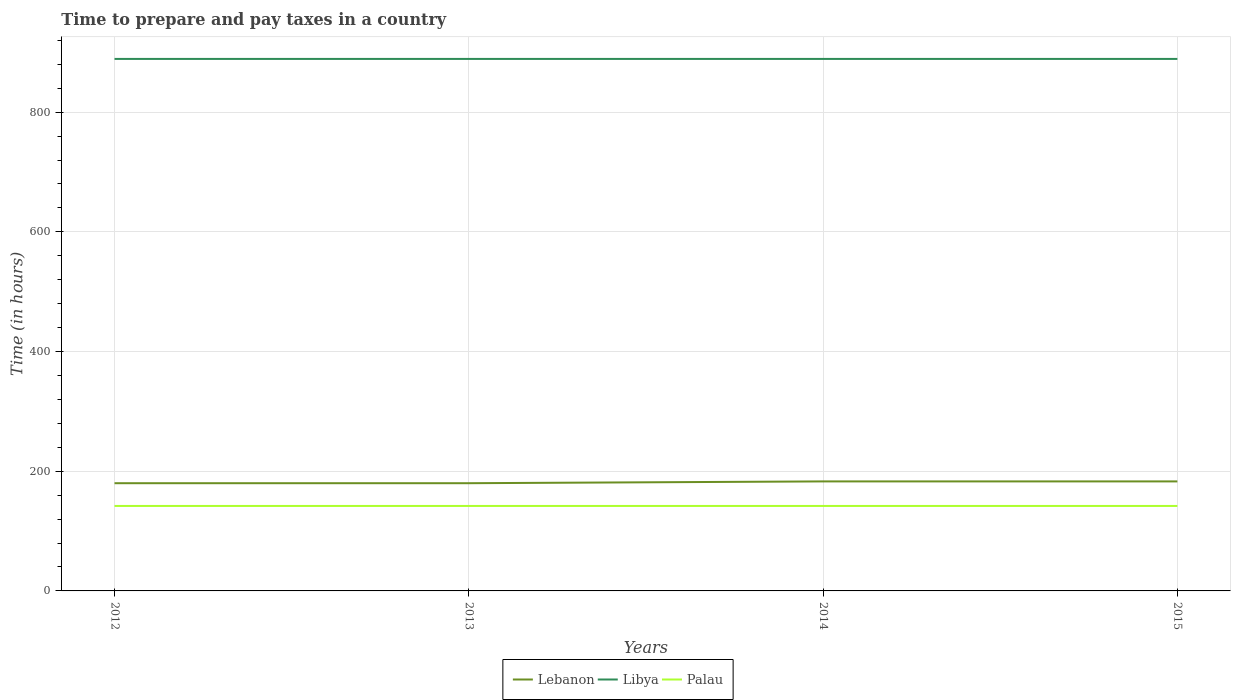Does the line corresponding to Libya intersect with the line corresponding to Palau?
Give a very brief answer. No. Across all years, what is the maximum number of hours required to prepare and pay taxes in Libya?
Ensure brevity in your answer.  889. In which year was the number of hours required to prepare and pay taxes in Palau maximum?
Ensure brevity in your answer.  2012. What is the difference between the highest and the second highest number of hours required to prepare and pay taxes in Lebanon?
Keep it short and to the point. 3. How many lines are there?
Offer a very short reply. 3. How many years are there in the graph?
Your response must be concise. 4. Are the values on the major ticks of Y-axis written in scientific E-notation?
Provide a short and direct response. No. Does the graph contain any zero values?
Offer a very short reply. No. How many legend labels are there?
Offer a very short reply. 3. What is the title of the graph?
Offer a terse response. Time to prepare and pay taxes in a country. Does "Papua New Guinea" appear as one of the legend labels in the graph?
Your response must be concise. No. What is the label or title of the X-axis?
Offer a very short reply. Years. What is the label or title of the Y-axis?
Provide a short and direct response. Time (in hours). What is the Time (in hours) in Lebanon in 2012?
Give a very brief answer. 180. What is the Time (in hours) in Libya in 2012?
Offer a terse response. 889. What is the Time (in hours) in Palau in 2012?
Provide a succinct answer. 142. What is the Time (in hours) in Lebanon in 2013?
Provide a short and direct response. 180. What is the Time (in hours) of Libya in 2013?
Make the answer very short. 889. What is the Time (in hours) in Palau in 2013?
Ensure brevity in your answer.  142. What is the Time (in hours) of Lebanon in 2014?
Provide a succinct answer. 183. What is the Time (in hours) of Libya in 2014?
Your answer should be compact. 889. What is the Time (in hours) in Palau in 2014?
Your answer should be very brief. 142. What is the Time (in hours) of Lebanon in 2015?
Make the answer very short. 183. What is the Time (in hours) of Libya in 2015?
Keep it short and to the point. 889. What is the Time (in hours) of Palau in 2015?
Keep it short and to the point. 142. Across all years, what is the maximum Time (in hours) of Lebanon?
Offer a terse response. 183. Across all years, what is the maximum Time (in hours) in Libya?
Offer a very short reply. 889. Across all years, what is the maximum Time (in hours) in Palau?
Keep it short and to the point. 142. Across all years, what is the minimum Time (in hours) of Lebanon?
Keep it short and to the point. 180. Across all years, what is the minimum Time (in hours) of Libya?
Give a very brief answer. 889. Across all years, what is the minimum Time (in hours) in Palau?
Ensure brevity in your answer.  142. What is the total Time (in hours) of Lebanon in the graph?
Ensure brevity in your answer.  726. What is the total Time (in hours) in Libya in the graph?
Keep it short and to the point. 3556. What is the total Time (in hours) in Palau in the graph?
Offer a terse response. 568. What is the difference between the Time (in hours) in Palau in 2012 and that in 2013?
Ensure brevity in your answer.  0. What is the difference between the Time (in hours) of Libya in 2012 and that in 2014?
Offer a terse response. 0. What is the difference between the Time (in hours) in Lebanon in 2012 and that in 2015?
Your response must be concise. -3. What is the difference between the Time (in hours) of Palau in 2013 and that in 2014?
Give a very brief answer. 0. What is the difference between the Time (in hours) in Lebanon in 2014 and that in 2015?
Make the answer very short. 0. What is the difference between the Time (in hours) in Libya in 2014 and that in 2015?
Your answer should be compact. 0. What is the difference between the Time (in hours) in Palau in 2014 and that in 2015?
Your answer should be compact. 0. What is the difference between the Time (in hours) of Lebanon in 2012 and the Time (in hours) of Libya in 2013?
Your response must be concise. -709. What is the difference between the Time (in hours) in Lebanon in 2012 and the Time (in hours) in Palau in 2013?
Provide a short and direct response. 38. What is the difference between the Time (in hours) of Libya in 2012 and the Time (in hours) of Palau in 2013?
Make the answer very short. 747. What is the difference between the Time (in hours) in Lebanon in 2012 and the Time (in hours) in Libya in 2014?
Keep it short and to the point. -709. What is the difference between the Time (in hours) in Libya in 2012 and the Time (in hours) in Palau in 2014?
Provide a short and direct response. 747. What is the difference between the Time (in hours) in Lebanon in 2012 and the Time (in hours) in Libya in 2015?
Your answer should be compact. -709. What is the difference between the Time (in hours) of Libya in 2012 and the Time (in hours) of Palau in 2015?
Ensure brevity in your answer.  747. What is the difference between the Time (in hours) in Lebanon in 2013 and the Time (in hours) in Libya in 2014?
Offer a terse response. -709. What is the difference between the Time (in hours) of Lebanon in 2013 and the Time (in hours) of Palau in 2014?
Your answer should be very brief. 38. What is the difference between the Time (in hours) in Libya in 2013 and the Time (in hours) in Palau in 2014?
Your response must be concise. 747. What is the difference between the Time (in hours) of Lebanon in 2013 and the Time (in hours) of Libya in 2015?
Offer a very short reply. -709. What is the difference between the Time (in hours) in Lebanon in 2013 and the Time (in hours) in Palau in 2015?
Give a very brief answer. 38. What is the difference between the Time (in hours) in Libya in 2013 and the Time (in hours) in Palau in 2015?
Provide a succinct answer. 747. What is the difference between the Time (in hours) of Lebanon in 2014 and the Time (in hours) of Libya in 2015?
Offer a very short reply. -706. What is the difference between the Time (in hours) in Libya in 2014 and the Time (in hours) in Palau in 2015?
Your answer should be very brief. 747. What is the average Time (in hours) in Lebanon per year?
Offer a terse response. 181.5. What is the average Time (in hours) of Libya per year?
Provide a short and direct response. 889. What is the average Time (in hours) of Palau per year?
Offer a terse response. 142. In the year 2012, what is the difference between the Time (in hours) of Lebanon and Time (in hours) of Libya?
Provide a short and direct response. -709. In the year 2012, what is the difference between the Time (in hours) of Libya and Time (in hours) of Palau?
Provide a succinct answer. 747. In the year 2013, what is the difference between the Time (in hours) in Lebanon and Time (in hours) in Libya?
Give a very brief answer. -709. In the year 2013, what is the difference between the Time (in hours) in Libya and Time (in hours) in Palau?
Keep it short and to the point. 747. In the year 2014, what is the difference between the Time (in hours) of Lebanon and Time (in hours) of Libya?
Give a very brief answer. -706. In the year 2014, what is the difference between the Time (in hours) in Libya and Time (in hours) in Palau?
Your response must be concise. 747. In the year 2015, what is the difference between the Time (in hours) of Lebanon and Time (in hours) of Libya?
Keep it short and to the point. -706. In the year 2015, what is the difference between the Time (in hours) of Lebanon and Time (in hours) of Palau?
Provide a succinct answer. 41. In the year 2015, what is the difference between the Time (in hours) in Libya and Time (in hours) in Palau?
Make the answer very short. 747. What is the ratio of the Time (in hours) in Lebanon in 2012 to that in 2014?
Your answer should be very brief. 0.98. What is the ratio of the Time (in hours) in Lebanon in 2012 to that in 2015?
Offer a terse response. 0.98. What is the ratio of the Time (in hours) of Palau in 2012 to that in 2015?
Your response must be concise. 1. What is the ratio of the Time (in hours) of Lebanon in 2013 to that in 2014?
Provide a succinct answer. 0.98. What is the ratio of the Time (in hours) in Libya in 2013 to that in 2014?
Offer a terse response. 1. What is the ratio of the Time (in hours) of Lebanon in 2013 to that in 2015?
Offer a very short reply. 0.98. What is the ratio of the Time (in hours) of Libya in 2013 to that in 2015?
Offer a terse response. 1. What is the ratio of the Time (in hours) in Lebanon in 2014 to that in 2015?
Offer a very short reply. 1. What is the ratio of the Time (in hours) of Libya in 2014 to that in 2015?
Provide a short and direct response. 1. What is the ratio of the Time (in hours) in Palau in 2014 to that in 2015?
Offer a very short reply. 1. What is the difference between the highest and the second highest Time (in hours) in Lebanon?
Provide a short and direct response. 0. What is the difference between the highest and the second highest Time (in hours) in Palau?
Offer a terse response. 0. What is the difference between the highest and the lowest Time (in hours) in Libya?
Keep it short and to the point. 0. What is the difference between the highest and the lowest Time (in hours) in Palau?
Your response must be concise. 0. 